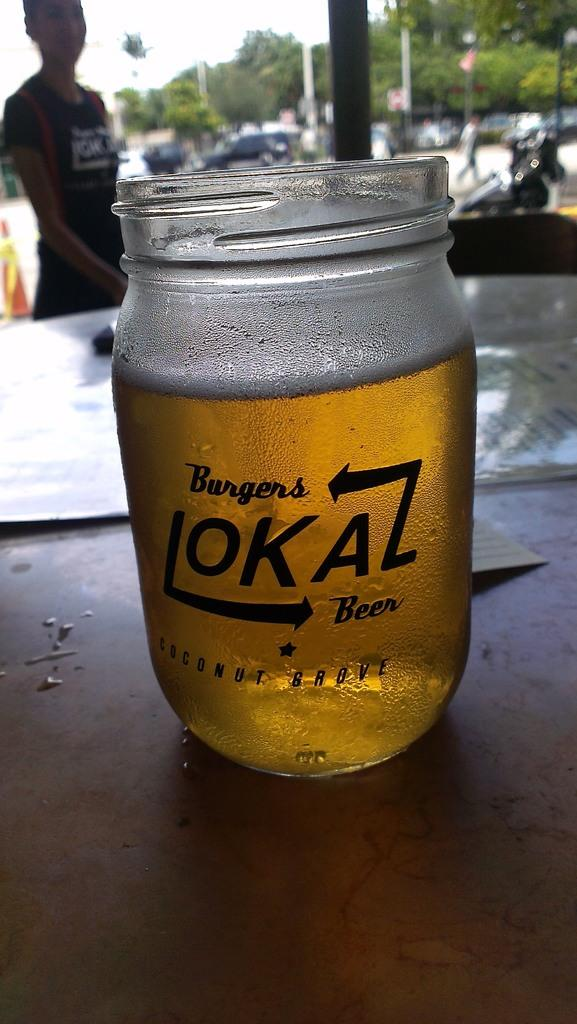What is in the jar that is visible in the image? There is a jar of beer in the image. What is the jar of beer placed on in the image? The jar of beer is on an object. Can you describe the person in the image? There is a person standing in the image. What else can be seen in the image besides the jar of beer and the person? Vehicles and trees are visible in the image. What is visible in the background of the image? The sky is visible in the background of the image. How many grams of salt are present in the image? There is no salt present in the image, so it is not possible to determine the amount. 